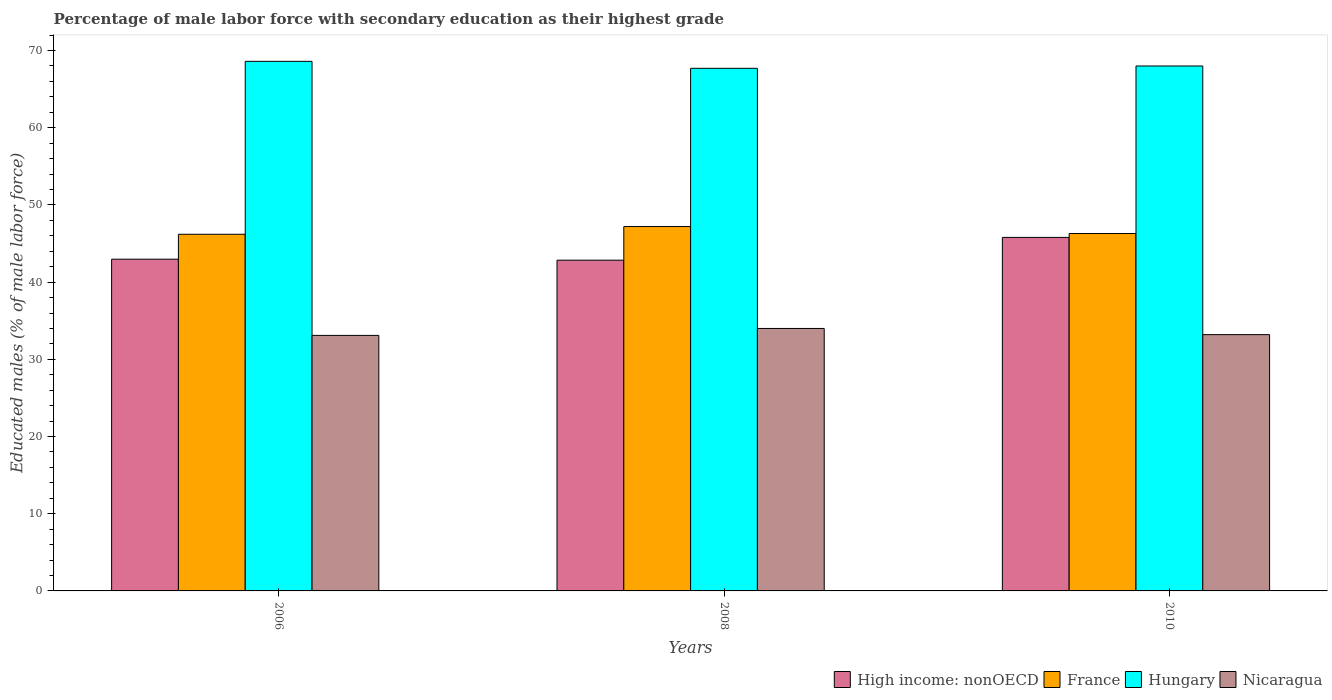How many different coloured bars are there?
Your answer should be compact. 4. How many bars are there on the 1st tick from the left?
Offer a very short reply. 4. How many bars are there on the 2nd tick from the right?
Offer a terse response. 4. In how many cases, is the number of bars for a given year not equal to the number of legend labels?
Your answer should be very brief. 0. What is the percentage of male labor force with secondary education in High income: nonOECD in 2006?
Make the answer very short. 42.97. Across all years, what is the maximum percentage of male labor force with secondary education in Hungary?
Provide a short and direct response. 68.6. Across all years, what is the minimum percentage of male labor force with secondary education in High income: nonOECD?
Your answer should be very brief. 42.84. What is the total percentage of male labor force with secondary education in Hungary in the graph?
Keep it short and to the point. 204.3. What is the difference between the percentage of male labor force with secondary education in France in 2008 and that in 2010?
Keep it short and to the point. 0.9. What is the difference between the percentage of male labor force with secondary education in Nicaragua in 2010 and the percentage of male labor force with secondary education in France in 2006?
Your answer should be very brief. -13. What is the average percentage of male labor force with secondary education in Nicaragua per year?
Offer a very short reply. 33.43. In the year 2010, what is the difference between the percentage of male labor force with secondary education in France and percentage of male labor force with secondary education in Hungary?
Your answer should be compact. -21.7. In how many years, is the percentage of male labor force with secondary education in Hungary greater than 10 %?
Your answer should be very brief. 3. What is the ratio of the percentage of male labor force with secondary education in High income: nonOECD in 2006 to that in 2008?
Provide a succinct answer. 1. What is the difference between the highest and the second highest percentage of male labor force with secondary education in Nicaragua?
Make the answer very short. 0.8. What is the difference between the highest and the lowest percentage of male labor force with secondary education in Hungary?
Your answer should be very brief. 0.9. Is the sum of the percentage of male labor force with secondary education in France in 2008 and 2010 greater than the maximum percentage of male labor force with secondary education in High income: nonOECD across all years?
Provide a succinct answer. Yes. What does the 1st bar from the left in 2010 represents?
Ensure brevity in your answer.  High income: nonOECD. What does the 2nd bar from the right in 2010 represents?
Give a very brief answer. Hungary. Is it the case that in every year, the sum of the percentage of male labor force with secondary education in Nicaragua and percentage of male labor force with secondary education in High income: nonOECD is greater than the percentage of male labor force with secondary education in France?
Give a very brief answer. Yes. How many years are there in the graph?
Your response must be concise. 3. Are the values on the major ticks of Y-axis written in scientific E-notation?
Offer a terse response. No. Does the graph contain any zero values?
Give a very brief answer. No. Where does the legend appear in the graph?
Make the answer very short. Bottom right. How many legend labels are there?
Keep it short and to the point. 4. What is the title of the graph?
Keep it short and to the point. Percentage of male labor force with secondary education as their highest grade. What is the label or title of the X-axis?
Keep it short and to the point. Years. What is the label or title of the Y-axis?
Ensure brevity in your answer.  Educated males (% of male labor force). What is the Educated males (% of male labor force) in High income: nonOECD in 2006?
Your answer should be compact. 42.97. What is the Educated males (% of male labor force) of France in 2006?
Provide a short and direct response. 46.2. What is the Educated males (% of male labor force) of Hungary in 2006?
Make the answer very short. 68.6. What is the Educated males (% of male labor force) in Nicaragua in 2006?
Your answer should be compact. 33.1. What is the Educated males (% of male labor force) in High income: nonOECD in 2008?
Ensure brevity in your answer.  42.84. What is the Educated males (% of male labor force) in France in 2008?
Provide a succinct answer. 47.2. What is the Educated males (% of male labor force) of Hungary in 2008?
Ensure brevity in your answer.  67.7. What is the Educated males (% of male labor force) of High income: nonOECD in 2010?
Provide a succinct answer. 45.79. What is the Educated males (% of male labor force) in France in 2010?
Ensure brevity in your answer.  46.3. What is the Educated males (% of male labor force) in Nicaragua in 2010?
Offer a very short reply. 33.2. Across all years, what is the maximum Educated males (% of male labor force) in High income: nonOECD?
Keep it short and to the point. 45.79. Across all years, what is the maximum Educated males (% of male labor force) of France?
Ensure brevity in your answer.  47.2. Across all years, what is the maximum Educated males (% of male labor force) of Hungary?
Provide a succinct answer. 68.6. Across all years, what is the maximum Educated males (% of male labor force) in Nicaragua?
Provide a short and direct response. 34. Across all years, what is the minimum Educated males (% of male labor force) in High income: nonOECD?
Give a very brief answer. 42.84. Across all years, what is the minimum Educated males (% of male labor force) in France?
Your answer should be very brief. 46.2. Across all years, what is the minimum Educated males (% of male labor force) of Hungary?
Give a very brief answer. 67.7. Across all years, what is the minimum Educated males (% of male labor force) in Nicaragua?
Provide a short and direct response. 33.1. What is the total Educated males (% of male labor force) in High income: nonOECD in the graph?
Your response must be concise. 131.61. What is the total Educated males (% of male labor force) in France in the graph?
Your answer should be compact. 139.7. What is the total Educated males (% of male labor force) of Hungary in the graph?
Make the answer very short. 204.3. What is the total Educated males (% of male labor force) of Nicaragua in the graph?
Ensure brevity in your answer.  100.3. What is the difference between the Educated males (% of male labor force) in High income: nonOECD in 2006 and that in 2008?
Your response must be concise. 0.13. What is the difference between the Educated males (% of male labor force) of France in 2006 and that in 2008?
Your answer should be very brief. -1. What is the difference between the Educated males (% of male labor force) in Nicaragua in 2006 and that in 2008?
Give a very brief answer. -0.9. What is the difference between the Educated males (% of male labor force) in High income: nonOECD in 2006 and that in 2010?
Your response must be concise. -2.82. What is the difference between the Educated males (% of male labor force) in France in 2006 and that in 2010?
Give a very brief answer. -0.1. What is the difference between the Educated males (% of male labor force) in Hungary in 2006 and that in 2010?
Provide a succinct answer. 0.6. What is the difference between the Educated males (% of male labor force) of Nicaragua in 2006 and that in 2010?
Your response must be concise. -0.1. What is the difference between the Educated males (% of male labor force) of High income: nonOECD in 2008 and that in 2010?
Offer a very short reply. -2.95. What is the difference between the Educated males (% of male labor force) in France in 2008 and that in 2010?
Provide a succinct answer. 0.9. What is the difference between the Educated males (% of male labor force) of Hungary in 2008 and that in 2010?
Make the answer very short. -0.3. What is the difference between the Educated males (% of male labor force) of Nicaragua in 2008 and that in 2010?
Provide a short and direct response. 0.8. What is the difference between the Educated males (% of male labor force) of High income: nonOECD in 2006 and the Educated males (% of male labor force) of France in 2008?
Offer a terse response. -4.23. What is the difference between the Educated males (% of male labor force) of High income: nonOECD in 2006 and the Educated males (% of male labor force) of Hungary in 2008?
Keep it short and to the point. -24.73. What is the difference between the Educated males (% of male labor force) of High income: nonOECD in 2006 and the Educated males (% of male labor force) of Nicaragua in 2008?
Provide a short and direct response. 8.97. What is the difference between the Educated males (% of male labor force) in France in 2006 and the Educated males (% of male labor force) in Hungary in 2008?
Keep it short and to the point. -21.5. What is the difference between the Educated males (% of male labor force) in France in 2006 and the Educated males (% of male labor force) in Nicaragua in 2008?
Offer a terse response. 12.2. What is the difference between the Educated males (% of male labor force) of Hungary in 2006 and the Educated males (% of male labor force) of Nicaragua in 2008?
Your response must be concise. 34.6. What is the difference between the Educated males (% of male labor force) of High income: nonOECD in 2006 and the Educated males (% of male labor force) of France in 2010?
Ensure brevity in your answer.  -3.33. What is the difference between the Educated males (% of male labor force) in High income: nonOECD in 2006 and the Educated males (% of male labor force) in Hungary in 2010?
Ensure brevity in your answer.  -25.03. What is the difference between the Educated males (% of male labor force) of High income: nonOECD in 2006 and the Educated males (% of male labor force) of Nicaragua in 2010?
Your response must be concise. 9.77. What is the difference between the Educated males (% of male labor force) in France in 2006 and the Educated males (% of male labor force) in Hungary in 2010?
Provide a succinct answer. -21.8. What is the difference between the Educated males (% of male labor force) of France in 2006 and the Educated males (% of male labor force) of Nicaragua in 2010?
Provide a succinct answer. 13. What is the difference between the Educated males (% of male labor force) in Hungary in 2006 and the Educated males (% of male labor force) in Nicaragua in 2010?
Your answer should be compact. 35.4. What is the difference between the Educated males (% of male labor force) in High income: nonOECD in 2008 and the Educated males (% of male labor force) in France in 2010?
Keep it short and to the point. -3.46. What is the difference between the Educated males (% of male labor force) in High income: nonOECD in 2008 and the Educated males (% of male labor force) in Hungary in 2010?
Your response must be concise. -25.16. What is the difference between the Educated males (% of male labor force) in High income: nonOECD in 2008 and the Educated males (% of male labor force) in Nicaragua in 2010?
Offer a very short reply. 9.64. What is the difference between the Educated males (% of male labor force) of France in 2008 and the Educated males (% of male labor force) of Hungary in 2010?
Your response must be concise. -20.8. What is the difference between the Educated males (% of male labor force) in France in 2008 and the Educated males (% of male labor force) in Nicaragua in 2010?
Offer a terse response. 14. What is the difference between the Educated males (% of male labor force) in Hungary in 2008 and the Educated males (% of male labor force) in Nicaragua in 2010?
Offer a terse response. 34.5. What is the average Educated males (% of male labor force) of High income: nonOECD per year?
Offer a terse response. 43.87. What is the average Educated males (% of male labor force) in France per year?
Your response must be concise. 46.57. What is the average Educated males (% of male labor force) of Hungary per year?
Provide a short and direct response. 68.1. What is the average Educated males (% of male labor force) in Nicaragua per year?
Provide a short and direct response. 33.43. In the year 2006, what is the difference between the Educated males (% of male labor force) of High income: nonOECD and Educated males (% of male labor force) of France?
Keep it short and to the point. -3.23. In the year 2006, what is the difference between the Educated males (% of male labor force) of High income: nonOECD and Educated males (% of male labor force) of Hungary?
Offer a terse response. -25.63. In the year 2006, what is the difference between the Educated males (% of male labor force) of High income: nonOECD and Educated males (% of male labor force) of Nicaragua?
Keep it short and to the point. 9.87. In the year 2006, what is the difference between the Educated males (% of male labor force) of France and Educated males (% of male labor force) of Hungary?
Offer a very short reply. -22.4. In the year 2006, what is the difference between the Educated males (% of male labor force) in Hungary and Educated males (% of male labor force) in Nicaragua?
Keep it short and to the point. 35.5. In the year 2008, what is the difference between the Educated males (% of male labor force) of High income: nonOECD and Educated males (% of male labor force) of France?
Make the answer very short. -4.36. In the year 2008, what is the difference between the Educated males (% of male labor force) of High income: nonOECD and Educated males (% of male labor force) of Hungary?
Your response must be concise. -24.86. In the year 2008, what is the difference between the Educated males (% of male labor force) of High income: nonOECD and Educated males (% of male labor force) of Nicaragua?
Your answer should be very brief. 8.84. In the year 2008, what is the difference between the Educated males (% of male labor force) in France and Educated males (% of male labor force) in Hungary?
Offer a very short reply. -20.5. In the year 2008, what is the difference between the Educated males (% of male labor force) in Hungary and Educated males (% of male labor force) in Nicaragua?
Your answer should be compact. 33.7. In the year 2010, what is the difference between the Educated males (% of male labor force) of High income: nonOECD and Educated males (% of male labor force) of France?
Your answer should be very brief. -0.51. In the year 2010, what is the difference between the Educated males (% of male labor force) of High income: nonOECD and Educated males (% of male labor force) of Hungary?
Provide a succinct answer. -22.21. In the year 2010, what is the difference between the Educated males (% of male labor force) in High income: nonOECD and Educated males (% of male labor force) in Nicaragua?
Provide a succinct answer. 12.59. In the year 2010, what is the difference between the Educated males (% of male labor force) in France and Educated males (% of male labor force) in Hungary?
Offer a very short reply. -21.7. In the year 2010, what is the difference between the Educated males (% of male labor force) of Hungary and Educated males (% of male labor force) of Nicaragua?
Keep it short and to the point. 34.8. What is the ratio of the Educated males (% of male labor force) of High income: nonOECD in 2006 to that in 2008?
Provide a succinct answer. 1. What is the ratio of the Educated males (% of male labor force) of France in 2006 to that in 2008?
Provide a succinct answer. 0.98. What is the ratio of the Educated males (% of male labor force) in Hungary in 2006 to that in 2008?
Make the answer very short. 1.01. What is the ratio of the Educated males (% of male labor force) in Nicaragua in 2006 to that in 2008?
Make the answer very short. 0.97. What is the ratio of the Educated males (% of male labor force) in High income: nonOECD in 2006 to that in 2010?
Give a very brief answer. 0.94. What is the ratio of the Educated males (% of male labor force) of Hungary in 2006 to that in 2010?
Offer a terse response. 1.01. What is the ratio of the Educated males (% of male labor force) in High income: nonOECD in 2008 to that in 2010?
Keep it short and to the point. 0.94. What is the ratio of the Educated males (% of male labor force) of France in 2008 to that in 2010?
Ensure brevity in your answer.  1.02. What is the ratio of the Educated males (% of male labor force) of Hungary in 2008 to that in 2010?
Your answer should be compact. 1. What is the ratio of the Educated males (% of male labor force) of Nicaragua in 2008 to that in 2010?
Offer a very short reply. 1.02. What is the difference between the highest and the second highest Educated males (% of male labor force) of High income: nonOECD?
Ensure brevity in your answer.  2.82. What is the difference between the highest and the second highest Educated males (% of male labor force) of Hungary?
Give a very brief answer. 0.6. What is the difference between the highest and the lowest Educated males (% of male labor force) in High income: nonOECD?
Offer a very short reply. 2.95. What is the difference between the highest and the lowest Educated males (% of male labor force) in Hungary?
Your answer should be very brief. 0.9. What is the difference between the highest and the lowest Educated males (% of male labor force) in Nicaragua?
Give a very brief answer. 0.9. 